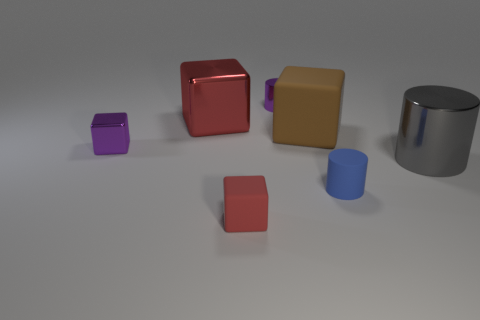Does the tiny metallic block have the same color as the tiny metallic cylinder?
Offer a very short reply. Yes. There is a large matte thing that is the same shape as the tiny red matte thing; what is its color?
Offer a very short reply. Brown. There is a thing that is both left of the tiny blue matte object and in front of the large gray cylinder; how big is it?
Your answer should be compact. Small. How many other things are there of the same color as the tiny shiny cube?
Give a very brief answer. 1. Is the material of the big object to the left of the red rubber object the same as the large brown cube?
Give a very brief answer. No. Is there any other thing that is the same size as the purple block?
Your response must be concise. Yes. Is the number of small purple cylinders right of the large brown thing less than the number of purple shiny blocks that are behind the tiny purple block?
Keep it short and to the point. No. Are there any other things that have the same shape as the large brown thing?
Your answer should be compact. Yes. There is a large thing that is the same color as the small matte block; what material is it?
Offer a terse response. Metal. There is a tiny cube that is in front of the small rubber thing that is behind the tiny rubber block; what number of metallic objects are right of it?
Your response must be concise. 2. 